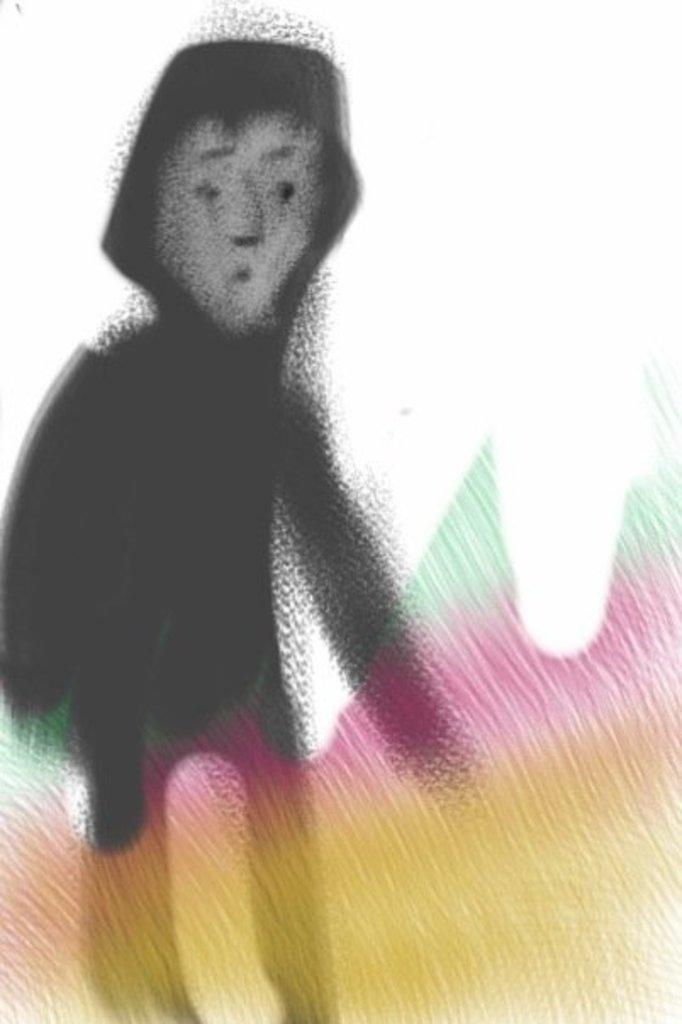What is depicted in the image? There is a drawing of a person in the image. What color is the background of the image? The background of the image is white. What type of lunch is being served at the farm in the image? There is no reference to a farm or lunch in the image, as it features a drawing of a person with a white background. 